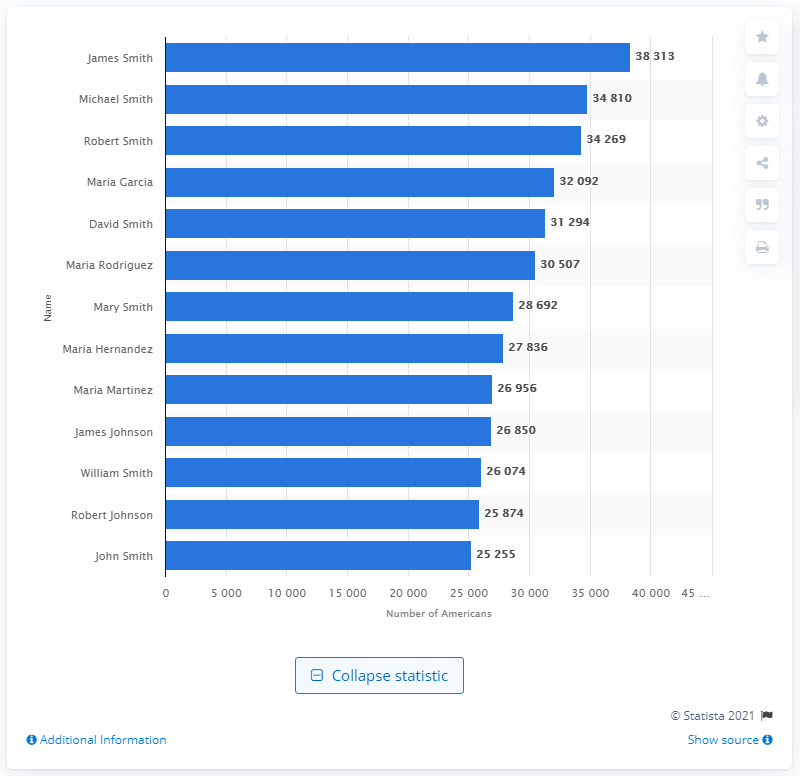Identify some key points in this picture. James Smith is the most popular name in the United States. 